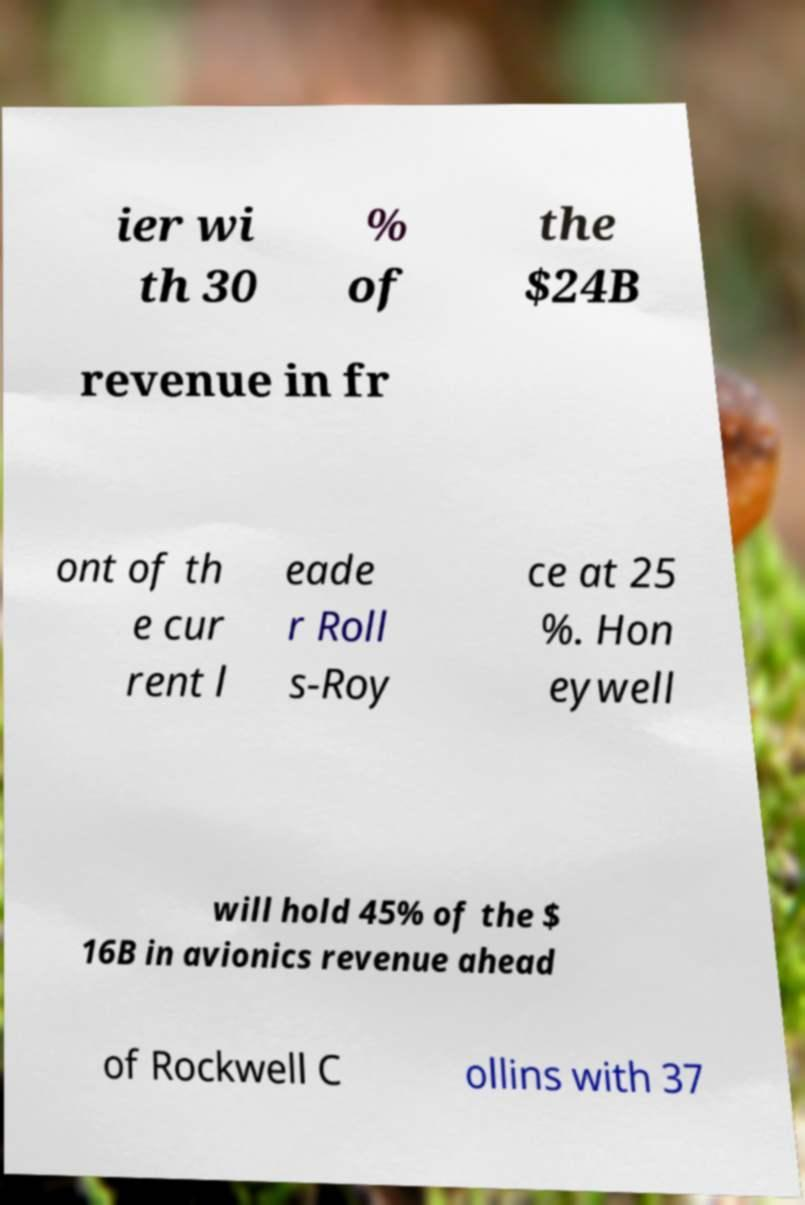What messages or text are displayed in this image? I need them in a readable, typed format. ier wi th 30 % of the $24B revenue in fr ont of th e cur rent l eade r Roll s-Roy ce at 25 %. Hon eywell will hold 45% of the $ 16B in avionics revenue ahead of Rockwell C ollins with 37 